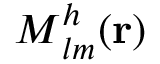Convert formula to latex. <formula><loc_0><loc_0><loc_500><loc_500>M _ { l m } ^ { h } ( { r } )</formula> 